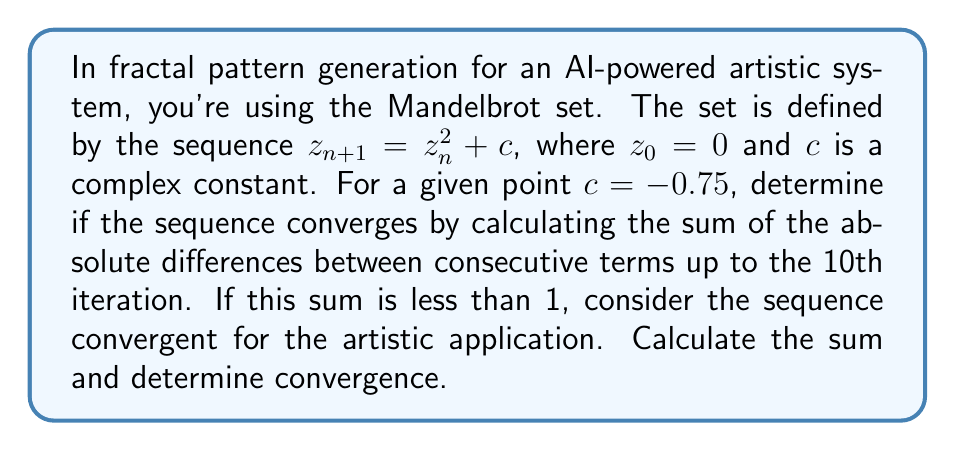Can you answer this question? Let's approach this step-by-step:

1) We start with $z_0 = 0$ and $c = -0.75$.

2) We'll calculate the first 10 terms of the sequence:

   $z_1 = 0^2 + (-0.75) = -0.75$
   $z_2 = (-0.75)^2 + (-0.75) = -0.1875$
   $z_3 = (-0.1875)^2 + (-0.75) = -0.7851563$
   $z_4 = (-0.7851563)^2 + (-0.75) = -0.1340342$
   $z_5 = (-0.1340342)^2 + (-0.75) = -0.7679654$
   $z_6 = (-0.7679654)^2 + (-0.75) = -0.1597705$
   $z_7 = (-0.1597705)^2 + (-0.75) = -0.7755132$
   $z_8 = (-0.7755132)^2 + (-0.75) = -0.1485431$
   $z_9 = (-0.1485431)^2 + (-0.75) = -0.7720535$
   $z_{10} = (-0.7720535)^2 + (-0.75) = -0.1540734$

3) Now, we calculate the absolute differences between consecutive terms:

   $|z_1 - z_0| = |-0.75 - 0| = 0.75$
   $|z_2 - z_1| = |-0.1875 - (-0.75)| = 0.5625$
   $|z_3 - z_2| = |-0.7851563 - (-0.1875)| = 0.5976563$
   $|z_4 - z_3| = |-0.1340342 - (-0.7851563)| = 0.6511221$
   $|z_5 - z_4| = |-0.7679654 - (-0.1340342)| = 0.6339312$
   $|z_6 - z_5| = |-0.1597705 - (-0.7679654)| = 0.6081949$
   $|z_7 - z_6| = |-0.7755132 - (-0.1597705)| = 0.6157427$
   $|z_8 - z_7| = |-0.1485431 - (-0.7755132)| = 0.6269701$
   $|z_9 - z_8| = |-0.7720535 - (-0.1485431)| = 0.6235104$
   $|z_{10} - z_9| = |-0.1540734 - (-0.7720535)| = 0.6179801$

4) Sum these differences:

   $S = 0.75 + 0.5625 + 0.5976563 + 0.6511221 + 0.6339312 + 0.6081949 + 0.6157427 + 0.6269701 + 0.6235104 + 0.6179801 = 6.2875578$

5) Compare the sum to 1:

   $6.2875578 > 1$

Therefore, the sum is greater than 1, so the sequence is considered non-convergent for this artistic application.
Answer: Non-convergent; sum = 6.2875578 > 1 